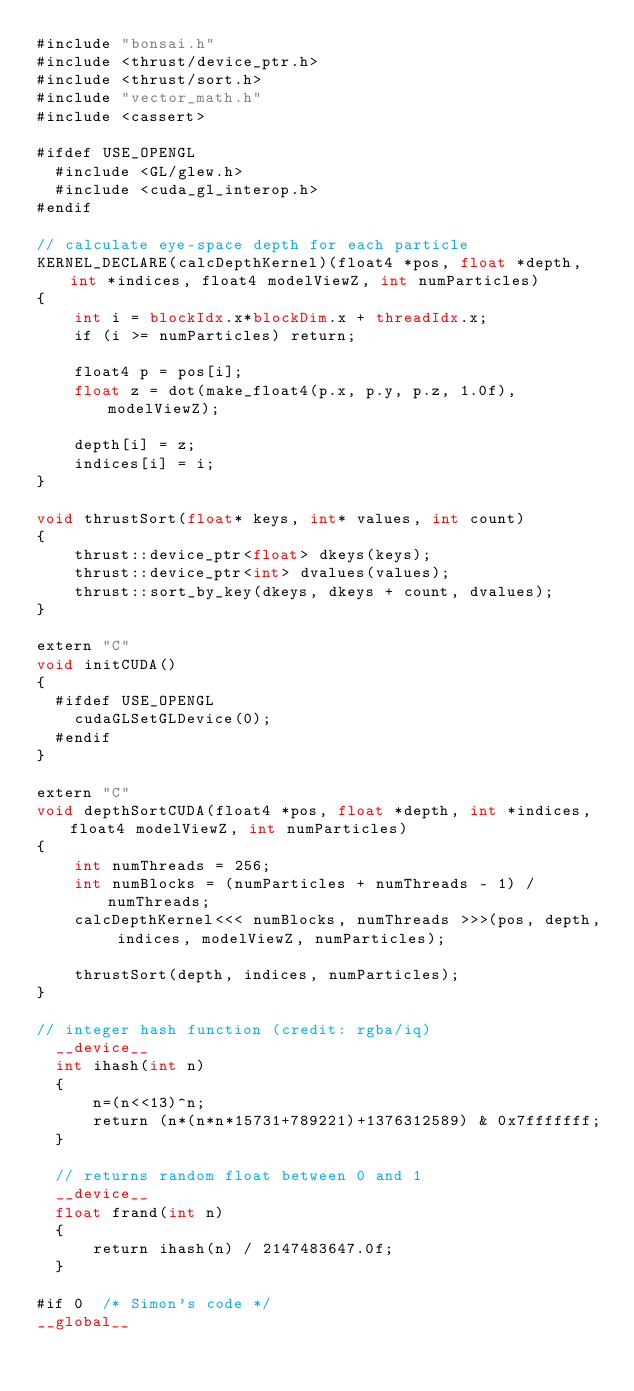<code> <loc_0><loc_0><loc_500><loc_500><_Cuda_>#include "bonsai.h"
#include <thrust/device_ptr.h>
#include <thrust/sort.h>
#include "vector_math.h"
#include <cassert>

#ifdef USE_OPENGL
  #include <GL/glew.h>
  #include <cuda_gl_interop.h>
#endif

// calculate eye-space depth for each particle
KERNEL_DECLARE(calcDepthKernel)(float4 *pos, float *depth, int *indices, float4 modelViewZ, int numParticles)
{
    int i = blockIdx.x*blockDim.x + threadIdx.x;
	if (i >= numParticles) return;

	float4 p = pos[i];
	float z = dot(make_float4(p.x, p.y, p.z, 1.0f), modelViewZ);
	
	depth[i] = z;
	indices[i] = i;
}

void thrustSort(float* keys, int* values, int count)
{
    thrust::device_ptr<float> dkeys(keys);
    thrust::device_ptr<int> dvalues(values);
    thrust::sort_by_key(dkeys, dkeys + count, dvalues);
}

extern "C"
void initCUDA()
{
  #ifdef USE_OPENGL
    cudaGLSetGLDevice(0);
  #endif
}

extern "C"
void depthSortCUDA(float4 *pos, float *depth, int *indices, float4 modelViewZ, int numParticles)
{
	int numThreads = 256;
	int numBlocks = (numParticles + numThreads - 1) / numThreads;
    calcDepthKernel<<< numBlocks, numThreads >>>(pos, depth, indices, modelViewZ, numParticles);

	thrustSort(depth, indices, numParticles);
}

// integer hash function (credit: rgba/iq)
  __device__
  int ihash(int n)
  {
      n=(n<<13)^n;
      return (n*(n*n*15731+789221)+1376312589) & 0x7fffffff;
  }

  // returns random float between 0 and 1
  __device__
  float frand(int n)
  {
	  return ihash(n) / 2147483647.0f;
  }

#if 0  /* Simon's code */
__global__</code> 